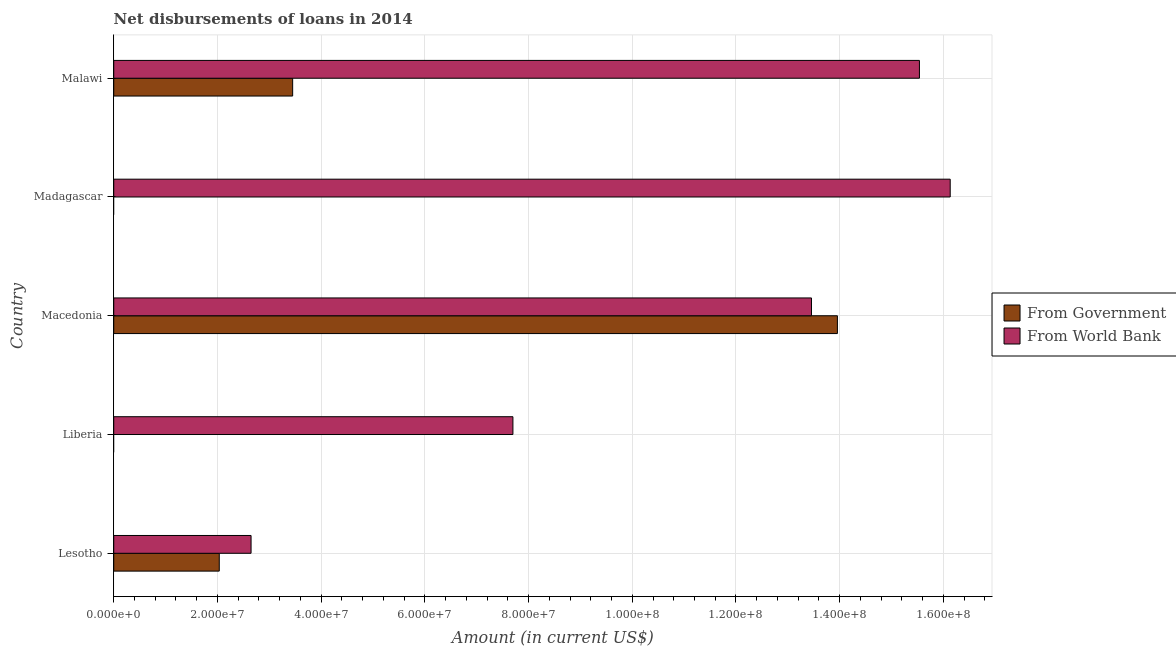How many different coloured bars are there?
Your answer should be very brief. 2. Are the number of bars per tick equal to the number of legend labels?
Provide a short and direct response. No. What is the label of the 5th group of bars from the top?
Provide a succinct answer. Lesotho. What is the net disbursements of loan from government in Malawi?
Your answer should be compact. 3.45e+07. Across all countries, what is the maximum net disbursements of loan from government?
Make the answer very short. 1.40e+08. In which country was the net disbursements of loan from government maximum?
Offer a terse response. Macedonia. What is the total net disbursements of loan from world bank in the graph?
Ensure brevity in your answer.  5.55e+08. What is the difference between the net disbursements of loan from world bank in Liberia and that in Macedonia?
Provide a succinct answer. -5.76e+07. What is the difference between the net disbursements of loan from world bank in Madagascar and the net disbursements of loan from government in Liberia?
Offer a very short reply. 1.61e+08. What is the average net disbursements of loan from world bank per country?
Your answer should be compact. 1.11e+08. What is the difference between the net disbursements of loan from government and net disbursements of loan from world bank in Malawi?
Your answer should be very brief. -1.21e+08. In how many countries, is the net disbursements of loan from government greater than 56000000 US$?
Make the answer very short. 1. What is the ratio of the net disbursements of loan from world bank in Liberia to that in Macedonia?
Keep it short and to the point. 0.57. Is the net disbursements of loan from world bank in Macedonia less than that in Madagascar?
Provide a short and direct response. Yes. Is the difference between the net disbursements of loan from government in Lesotho and Malawi greater than the difference between the net disbursements of loan from world bank in Lesotho and Malawi?
Ensure brevity in your answer.  Yes. What is the difference between the highest and the second highest net disbursements of loan from world bank?
Keep it short and to the point. 5.93e+06. What is the difference between the highest and the lowest net disbursements of loan from world bank?
Your answer should be very brief. 1.35e+08. In how many countries, is the net disbursements of loan from world bank greater than the average net disbursements of loan from world bank taken over all countries?
Keep it short and to the point. 3. How many bars are there?
Your answer should be compact. 8. Are all the bars in the graph horizontal?
Offer a very short reply. Yes. Are the values on the major ticks of X-axis written in scientific E-notation?
Keep it short and to the point. Yes. Where does the legend appear in the graph?
Ensure brevity in your answer.  Center right. How many legend labels are there?
Make the answer very short. 2. What is the title of the graph?
Your answer should be very brief. Net disbursements of loans in 2014. What is the label or title of the X-axis?
Your answer should be compact. Amount (in current US$). What is the label or title of the Y-axis?
Offer a very short reply. Country. What is the Amount (in current US$) of From Government in Lesotho?
Give a very brief answer. 2.04e+07. What is the Amount (in current US$) of From World Bank in Lesotho?
Provide a succinct answer. 2.65e+07. What is the Amount (in current US$) in From Government in Liberia?
Ensure brevity in your answer.  0. What is the Amount (in current US$) of From World Bank in Liberia?
Offer a terse response. 7.70e+07. What is the Amount (in current US$) in From Government in Macedonia?
Make the answer very short. 1.40e+08. What is the Amount (in current US$) in From World Bank in Macedonia?
Provide a succinct answer. 1.35e+08. What is the Amount (in current US$) in From Government in Madagascar?
Your response must be concise. 0. What is the Amount (in current US$) of From World Bank in Madagascar?
Offer a very short reply. 1.61e+08. What is the Amount (in current US$) in From Government in Malawi?
Make the answer very short. 3.45e+07. What is the Amount (in current US$) of From World Bank in Malawi?
Your answer should be very brief. 1.55e+08. Across all countries, what is the maximum Amount (in current US$) in From Government?
Your response must be concise. 1.40e+08. Across all countries, what is the maximum Amount (in current US$) of From World Bank?
Provide a succinct answer. 1.61e+08. Across all countries, what is the minimum Amount (in current US$) in From Government?
Provide a short and direct response. 0. Across all countries, what is the minimum Amount (in current US$) of From World Bank?
Provide a short and direct response. 2.65e+07. What is the total Amount (in current US$) of From Government in the graph?
Provide a succinct answer. 1.94e+08. What is the total Amount (in current US$) in From World Bank in the graph?
Ensure brevity in your answer.  5.55e+08. What is the difference between the Amount (in current US$) in From World Bank in Lesotho and that in Liberia?
Give a very brief answer. -5.05e+07. What is the difference between the Amount (in current US$) in From Government in Lesotho and that in Macedonia?
Provide a succinct answer. -1.19e+08. What is the difference between the Amount (in current US$) of From World Bank in Lesotho and that in Macedonia?
Give a very brief answer. -1.08e+08. What is the difference between the Amount (in current US$) of From World Bank in Lesotho and that in Madagascar?
Give a very brief answer. -1.35e+08. What is the difference between the Amount (in current US$) in From Government in Lesotho and that in Malawi?
Make the answer very short. -1.42e+07. What is the difference between the Amount (in current US$) of From World Bank in Lesotho and that in Malawi?
Give a very brief answer. -1.29e+08. What is the difference between the Amount (in current US$) in From World Bank in Liberia and that in Macedonia?
Your answer should be very brief. -5.76e+07. What is the difference between the Amount (in current US$) of From World Bank in Liberia and that in Madagascar?
Your response must be concise. -8.43e+07. What is the difference between the Amount (in current US$) in From World Bank in Liberia and that in Malawi?
Ensure brevity in your answer.  -7.84e+07. What is the difference between the Amount (in current US$) in From World Bank in Macedonia and that in Madagascar?
Your answer should be compact. -2.68e+07. What is the difference between the Amount (in current US$) in From Government in Macedonia and that in Malawi?
Offer a very short reply. 1.05e+08. What is the difference between the Amount (in current US$) of From World Bank in Macedonia and that in Malawi?
Your response must be concise. -2.08e+07. What is the difference between the Amount (in current US$) in From World Bank in Madagascar and that in Malawi?
Provide a succinct answer. 5.93e+06. What is the difference between the Amount (in current US$) in From Government in Lesotho and the Amount (in current US$) in From World Bank in Liberia?
Your answer should be very brief. -5.66e+07. What is the difference between the Amount (in current US$) of From Government in Lesotho and the Amount (in current US$) of From World Bank in Macedonia?
Your response must be concise. -1.14e+08. What is the difference between the Amount (in current US$) of From Government in Lesotho and the Amount (in current US$) of From World Bank in Madagascar?
Your answer should be compact. -1.41e+08. What is the difference between the Amount (in current US$) in From Government in Lesotho and the Amount (in current US$) in From World Bank in Malawi?
Your answer should be compact. -1.35e+08. What is the difference between the Amount (in current US$) in From Government in Macedonia and the Amount (in current US$) in From World Bank in Madagascar?
Offer a very short reply. -2.18e+07. What is the difference between the Amount (in current US$) in From Government in Macedonia and the Amount (in current US$) in From World Bank in Malawi?
Keep it short and to the point. -1.58e+07. What is the average Amount (in current US$) of From Government per country?
Provide a succinct answer. 3.89e+07. What is the average Amount (in current US$) of From World Bank per country?
Your answer should be very brief. 1.11e+08. What is the difference between the Amount (in current US$) in From Government and Amount (in current US$) in From World Bank in Lesotho?
Provide a short and direct response. -6.13e+06. What is the difference between the Amount (in current US$) of From Government and Amount (in current US$) of From World Bank in Macedonia?
Keep it short and to the point. 5.00e+06. What is the difference between the Amount (in current US$) in From Government and Amount (in current US$) in From World Bank in Malawi?
Give a very brief answer. -1.21e+08. What is the ratio of the Amount (in current US$) of From World Bank in Lesotho to that in Liberia?
Your answer should be very brief. 0.34. What is the ratio of the Amount (in current US$) in From Government in Lesotho to that in Macedonia?
Give a very brief answer. 0.15. What is the ratio of the Amount (in current US$) of From World Bank in Lesotho to that in Macedonia?
Ensure brevity in your answer.  0.2. What is the ratio of the Amount (in current US$) in From World Bank in Lesotho to that in Madagascar?
Give a very brief answer. 0.16. What is the ratio of the Amount (in current US$) in From Government in Lesotho to that in Malawi?
Offer a very short reply. 0.59. What is the ratio of the Amount (in current US$) of From World Bank in Lesotho to that in Malawi?
Provide a short and direct response. 0.17. What is the ratio of the Amount (in current US$) in From World Bank in Liberia to that in Macedonia?
Your answer should be very brief. 0.57. What is the ratio of the Amount (in current US$) of From World Bank in Liberia to that in Madagascar?
Offer a very short reply. 0.48. What is the ratio of the Amount (in current US$) in From World Bank in Liberia to that in Malawi?
Offer a terse response. 0.5. What is the ratio of the Amount (in current US$) in From World Bank in Macedonia to that in Madagascar?
Your answer should be very brief. 0.83. What is the ratio of the Amount (in current US$) in From Government in Macedonia to that in Malawi?
Provide a short and direct response. 4.04. What is the ratio of the Amount (in current US$) of From World Bank in Macedonia to that in Malawi?
Give a very brief answer. 0.87. What is the ratio of the Amount (in current US$) in From World Bank in Madagascar to that in Malawi?
Your answer should be very brief. 1.04. What is the difference between the highest and the second highest Amount (in current US$) of From Government?
Your response must be concise. 1.05e+08. What is the difference between the highest and the second highest Amount (in current US$) in From World Bank?
Provide a short and direct response. 5.93e+06. What is the difference between the highest and the lowest Amount (in current US$) of From Government?
Your response must be concise. 1.40e+08. What is the difference between the highest and the lowest Amount (in current US$) of From World Bank?
Your answer should be very brief. 1.35e+08. 